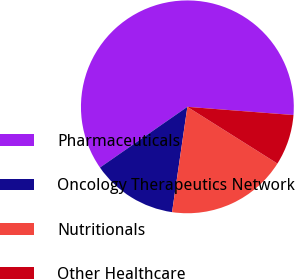Convert chart. <chart><loc_0><loc_0><loc_500><loc_500><pie_chart><fcel>Pharmaceuticals<fcel>Oncology Therapeutics Network<fcel>Nutritionals<fcel>Other Healthcare<nl><fcel>60.89%<fcel>13.04%<fcel>18.35%<fcel>7.72%<nl></chart> 